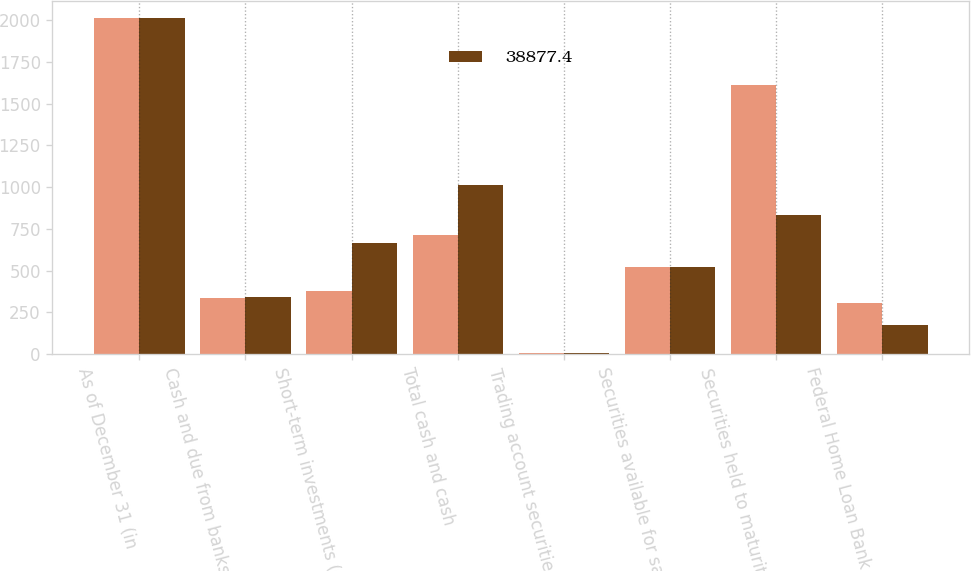Convert chart. <chart><loc_0><loc_0><loc_500><loc_500><stacked_bar_chart><ecel><fcel>As of December 31 (in<fcel>Cash and due from banks (note<fcel>Short-term investments (note<fcel>Total cash and cash<fcel>Trading account securities at<fcel>Securities available for sale<fcel>Securities held to maturity at<fcel>Federal Home Loan Bank and<nl><fcel>nan<fcel>2015<fcel>334.8<fcel>380.5<fcel>715.3<fcel>6.7<fcel>524.55<fcel>1609.6<fcel>305.4<nl><fcel>38877.4<fcel>2014<fcel>345.1<fcel>668.6<fcel>1013.7<fcel>8.3<fcel>524.55<fcel>834.3<fcel>175.7<nl></chart> 